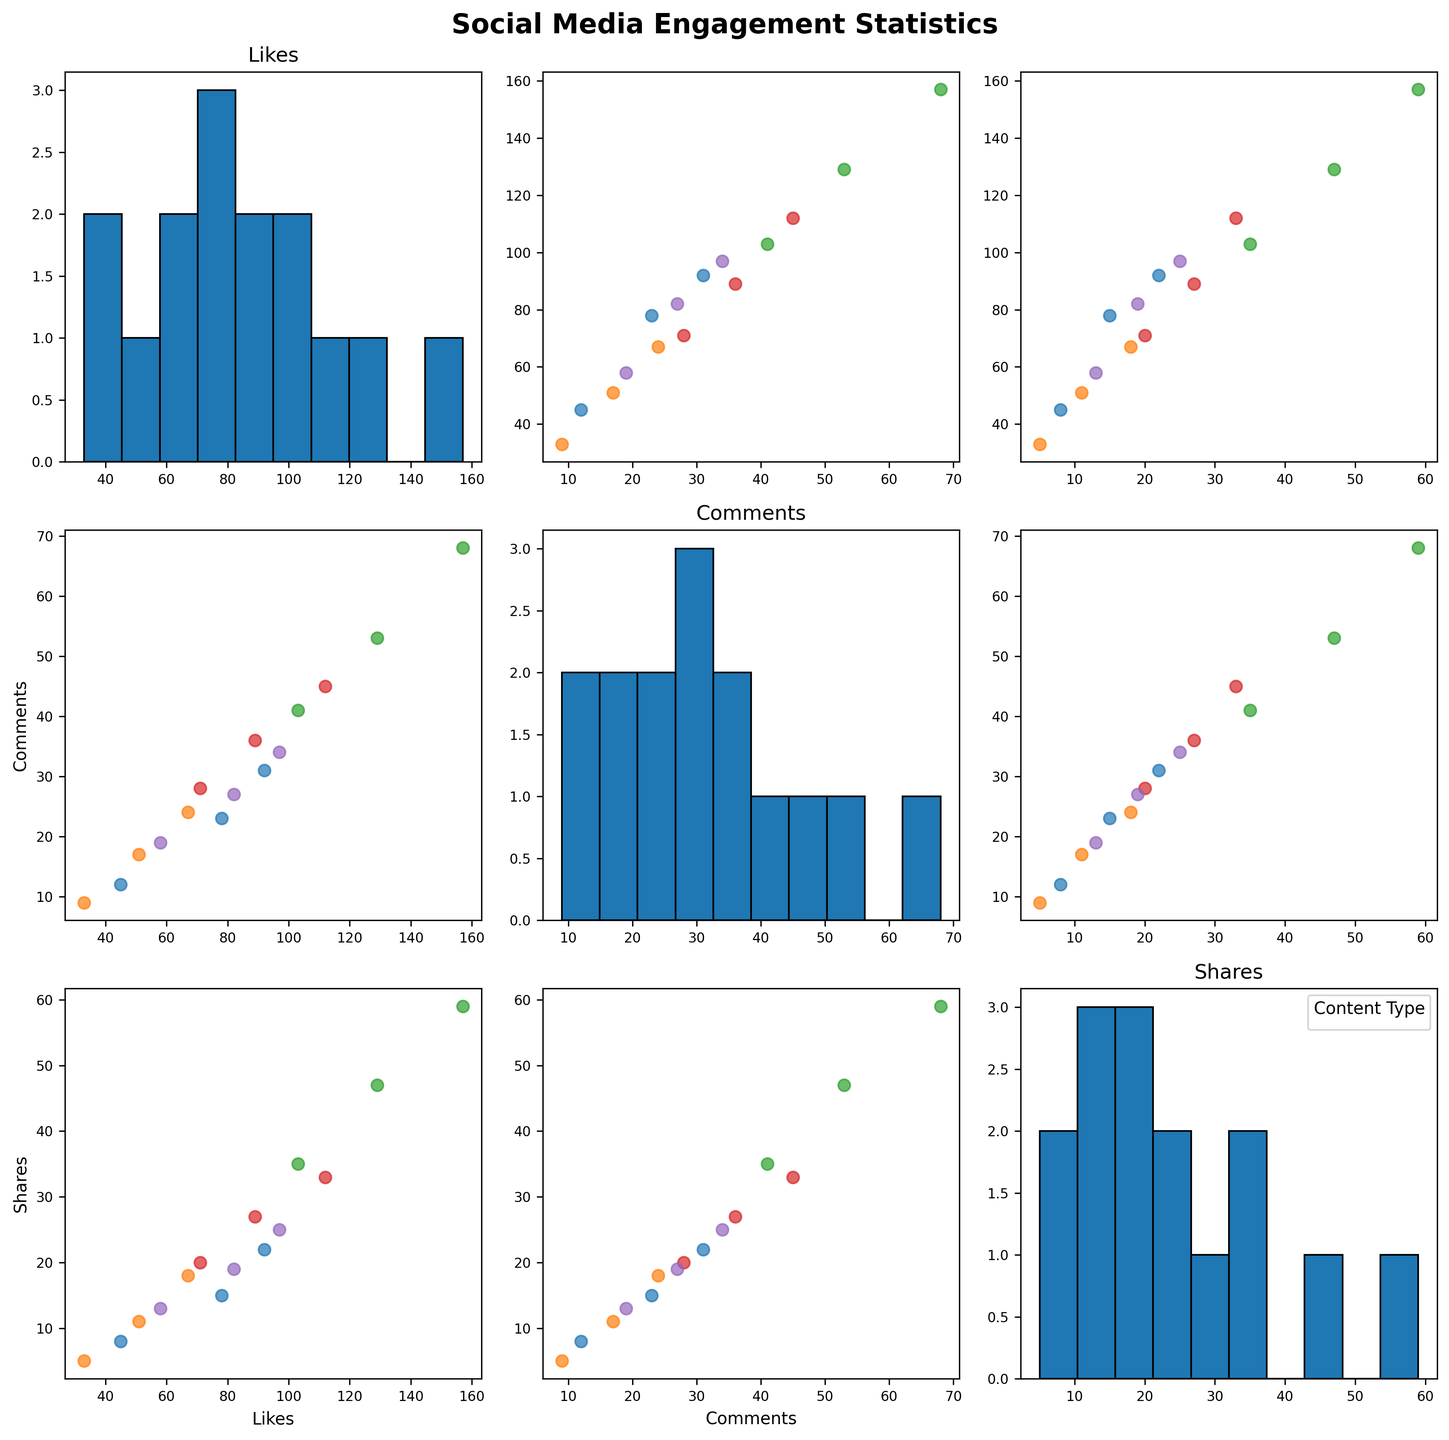What is the title of the scatterplot matrix? The title of the scatterplot matrix is often located at the top and is the largest text element. In this case, the title reads "Social Media Engagement Statistics".
Answer: Social Media Engagement Statistics How many unique content types are represented by different colors in the scatterplot matrix? The legend in the bottom right subplot shows different colors, each representing a content type. Counting these distinct categories gives us the number of unique content types. There are five content types displayed: Food Photo, Behind the Scenes, Special Offer, Cleanup Event, and Customer Review.
Answer: 5 Which type of content has the highest number of likes and at what time of day? By observing the scatter points in the "Likes" axis, we can identify the highest point. The highest number of likes is seen for "Special Offer" at 5 PM.
Answer: Special Offer at 5 PM What content type generally receives the highest number of comments? By observing the scatter points in the "Comments" vs each other metrics, we see that "Special Offer" consistently has higher values in comments, indicated by dots placed higher along the Comments axis.
Answer: Special Offer Which content type tends to have higher variability in the number of shares? To determine variability, we look at the spread of dots in the "Shares" axis for each content type. "Special Offer" has data points that are more spread out than others, indicating higher variability in shares.
Answer: Special Offer Is there a positive correlation between likes and shares across all content types? By examining the "Likes" vs "Shares" scatter plots, we observe that higher numbers of likes generally correspond to higher shares for all content types, indicating a positive correlation.
Answer: Yes Among food photos, which time of day witnesses the most engagement in likes? By observing just the "Food Photo" data in the scatter plots along the "Likes" axis, the highest engagement in likes is seen at 6 PM.
Answer: 6 PM Do cleanup events tend to get more shares in the morning or afternoon? By comparing the scatter points for "Cleanup Event" between morning (8 AM) and afternoon (12 PM, 4 PM) in the "Shares" axis, we see more shares in the afternoon time points.
Answer: Afternoon For a content type with medium engagement, such as Behind the Scenes, what's the average number of comments received throughout the day? Summing up the number of comments for Behind the Scenes (9 + 17 + 24) and dividing by the number of data points (3) gives the average: (9 + 17 + 24) / 3 = 16.7
Answer: 16.7 Are customer reviews or food photos more likely to receive a moderate number of comments, let's say within the range of 20-30 comments? By checking the scatter points for "Customer Review" and "Food Photo" within the 20-30 range along the "Comments" axis, Customer Reviews have one data point and Food Photos have no data points in that range.
Answer: Customer Reviews 